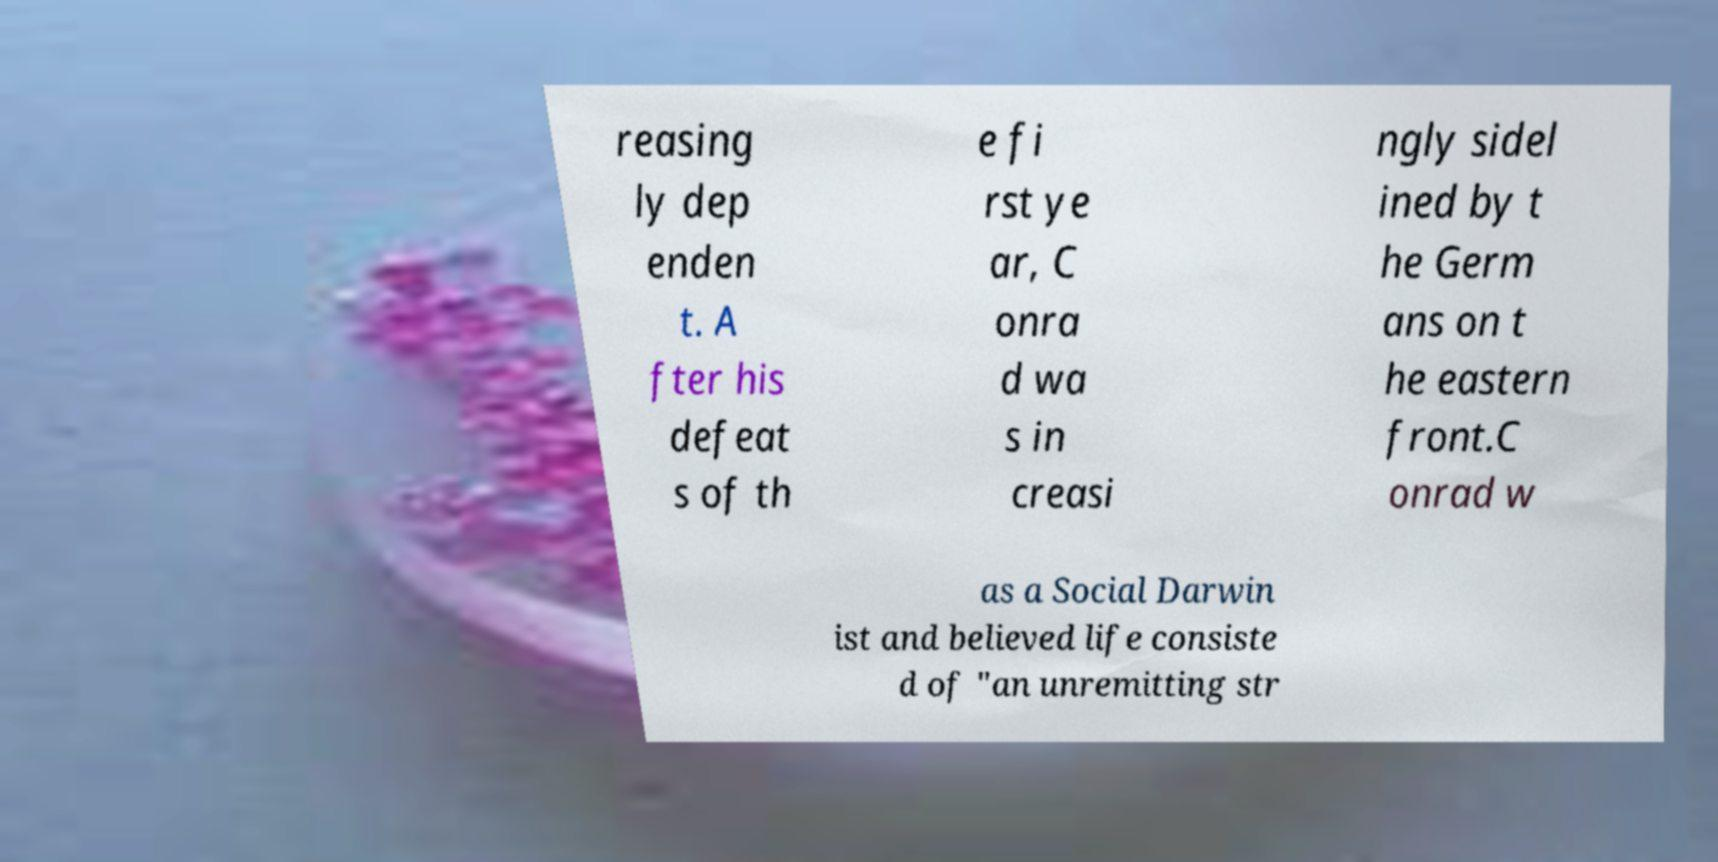Can you accurately transcribe the text from the provided image for me? reasing ly dep enden t. A fter his defeat s of th e fi rst ye ar, C onra d wa s in creasi ngly sidel ined by t he Germ ans on t he eastern front.C onrad w as a Social Darwin ist and believed life consiste d of "an unremitting str 